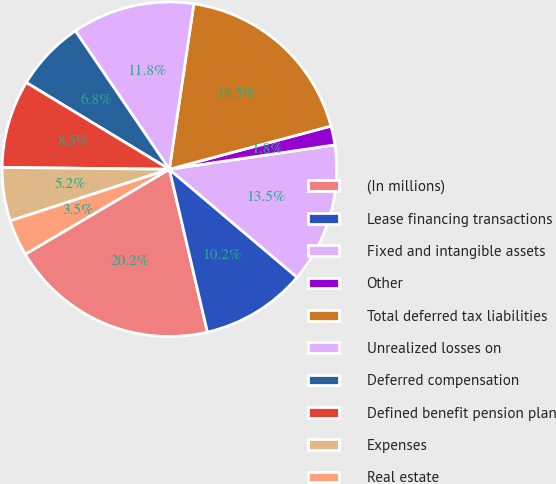<chart> <loc_0><loc_0><loc_500><loc_500><pie_chart><fcel>(In millions)<fcel>Lease financing transactions<fcel>Fixed and intangible assets<fcel>Other<fcel>Total deferred tax liabilities<fcel>Unrealized losses on<fcel>Deferred compensation<fcel>Defined benefit pension plan<fcel>Expenses<fcel>Real estate<nl><fcel>20.17%<fcel>10.17%<fcel>13.5%<fcel>1.83%<fcel>18.51%<fcel>11.83%<fcel>6.83%<fcel>8.5%<fcel>5.16%<fcel>3.49%<nl></chart> 